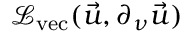Convert formula to latex. <formula><loc_0><loc_0><loc_500><loc_500>\mathcal { L } _ { v e c } ( \vec { u } , \partial _ { \nu } \vec { u } )</formula> 